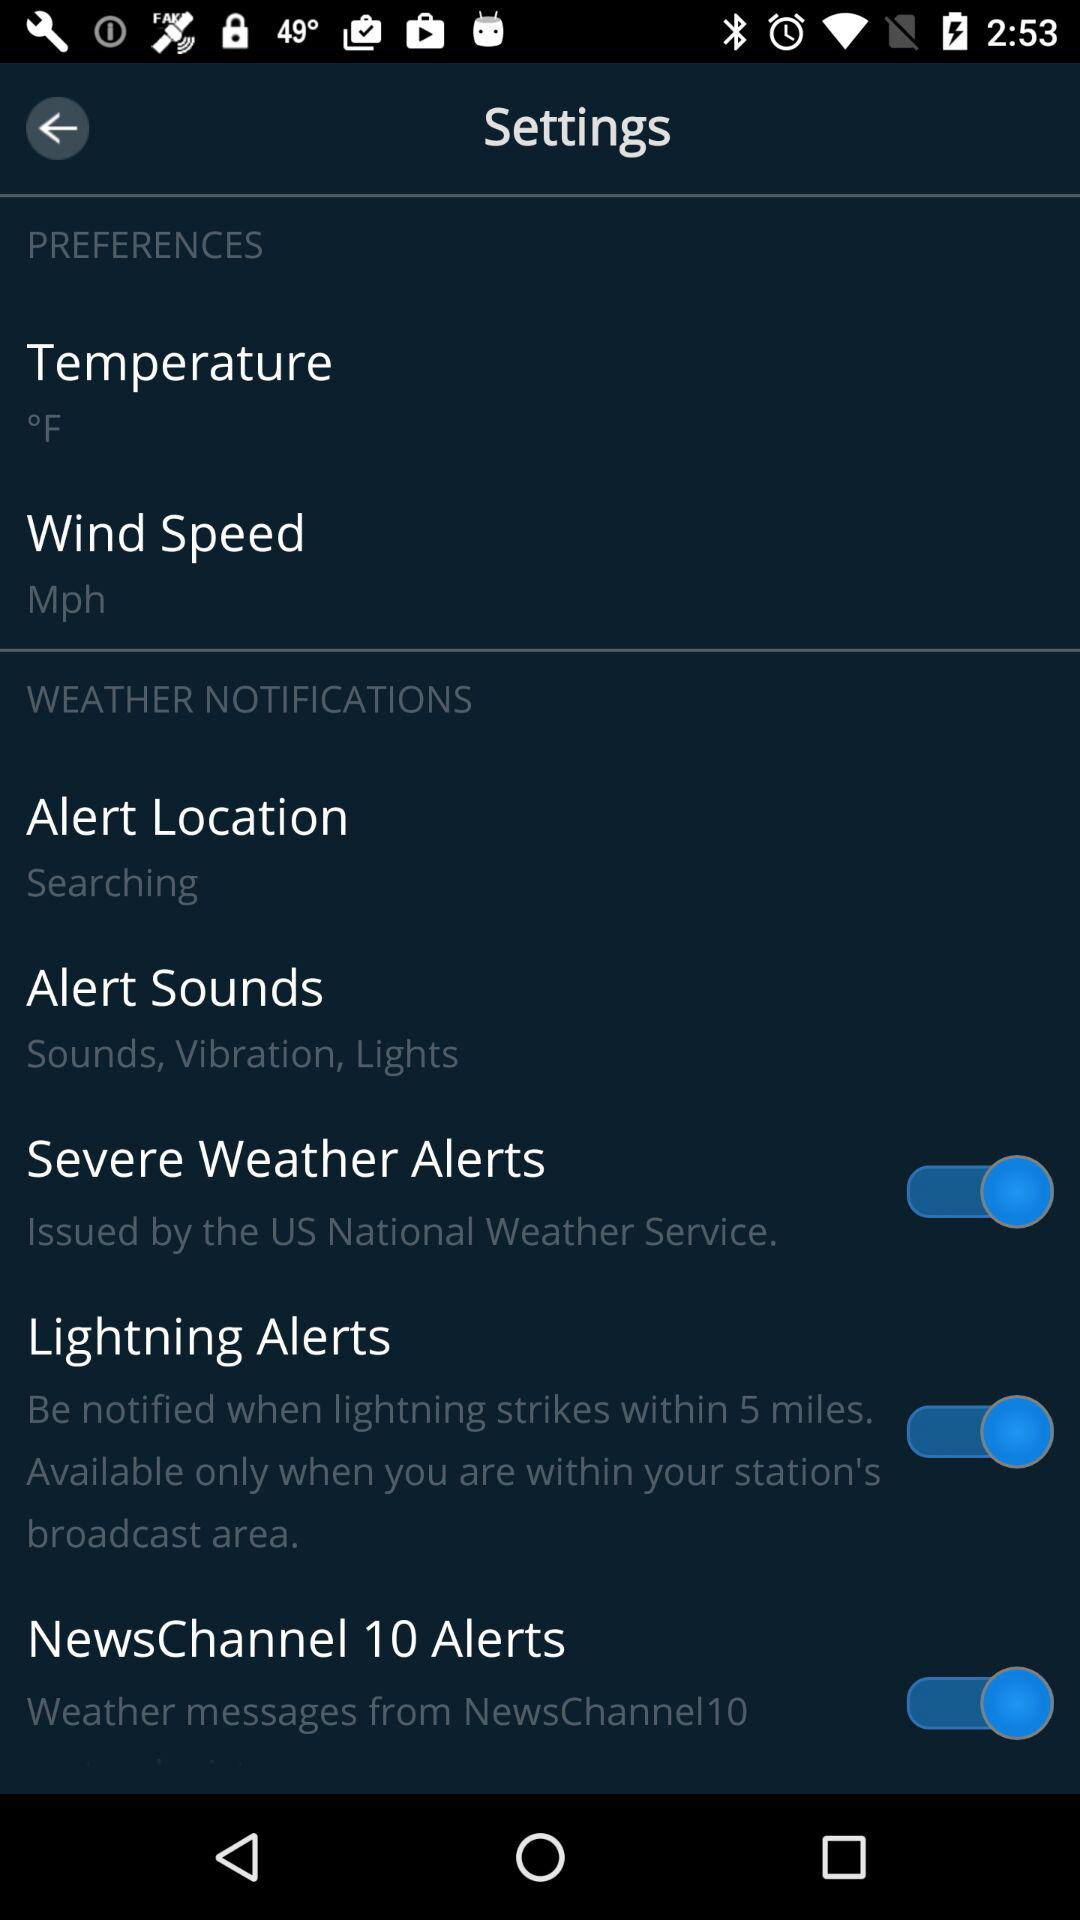What is the status of Weather Notifications?
When the provided information is insufficient, respond with <no answer>. <no answer> 